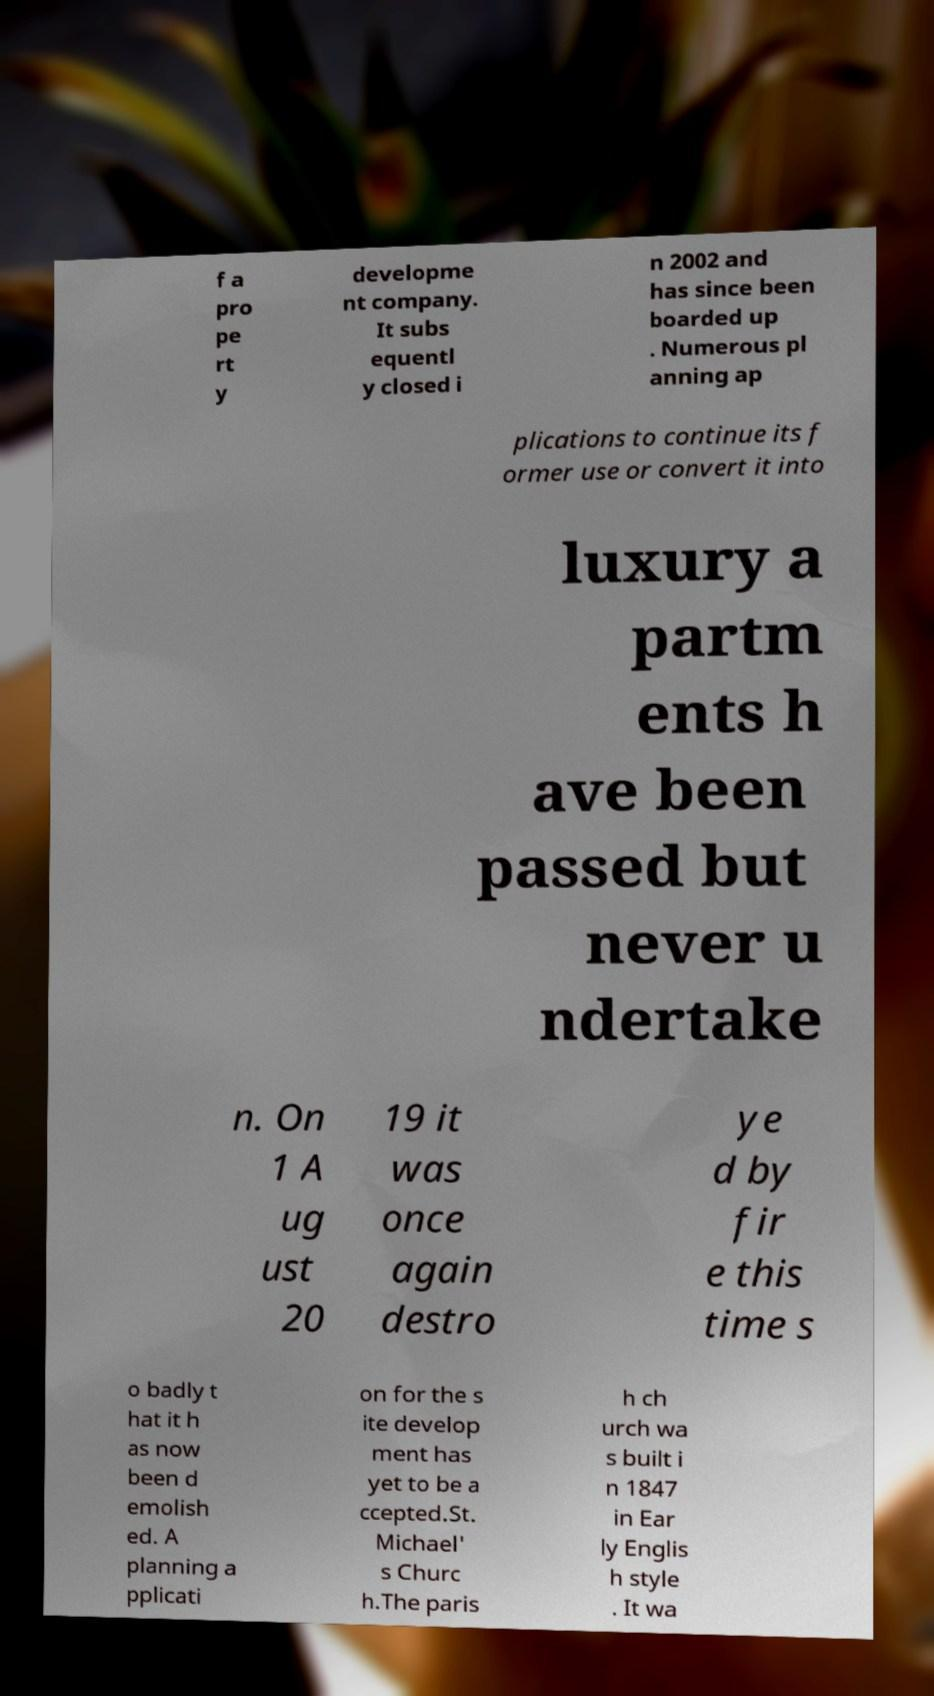Could you extract and type out the text from this image? f a pro pe rt y developme nt company. It subs equentl y closed i n 2002 and has since been boarded up . Numerous pl anning ap plications to continue its f ormer use or convert it into luxury a partm ents h ave been passed but never u ndertake n. On 1 A ug ust 20 19 it was once again destro ye d by fir e this time s o badly t hat it h as now been d emolish ed. A planning a pplicati on for the s ite develop ment has yet to be a ccepted.St. Michael' s Churc h.The paris h ch urch wa s built i n 1847 in Ear ly Englis h style . It wa 